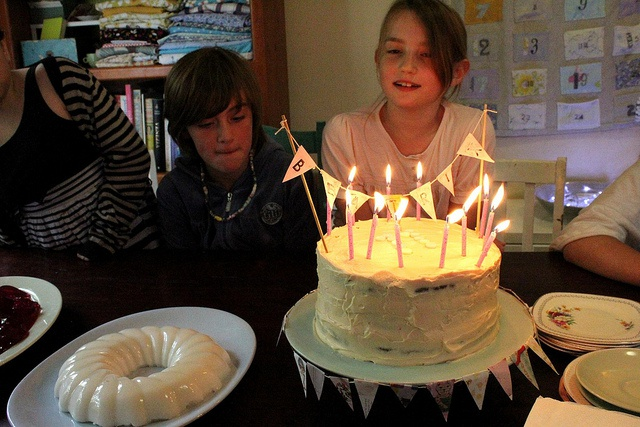Describe the objects in this image and their specific colors. I can see people in black, maroon, gray, and darkgray tones, people in black, maroon, and gray tones, cake in black, khaki, and olive tones, dining table in black, gray, and maroon tones, and people in black, salmon, brown, and maroon tones in this image. 